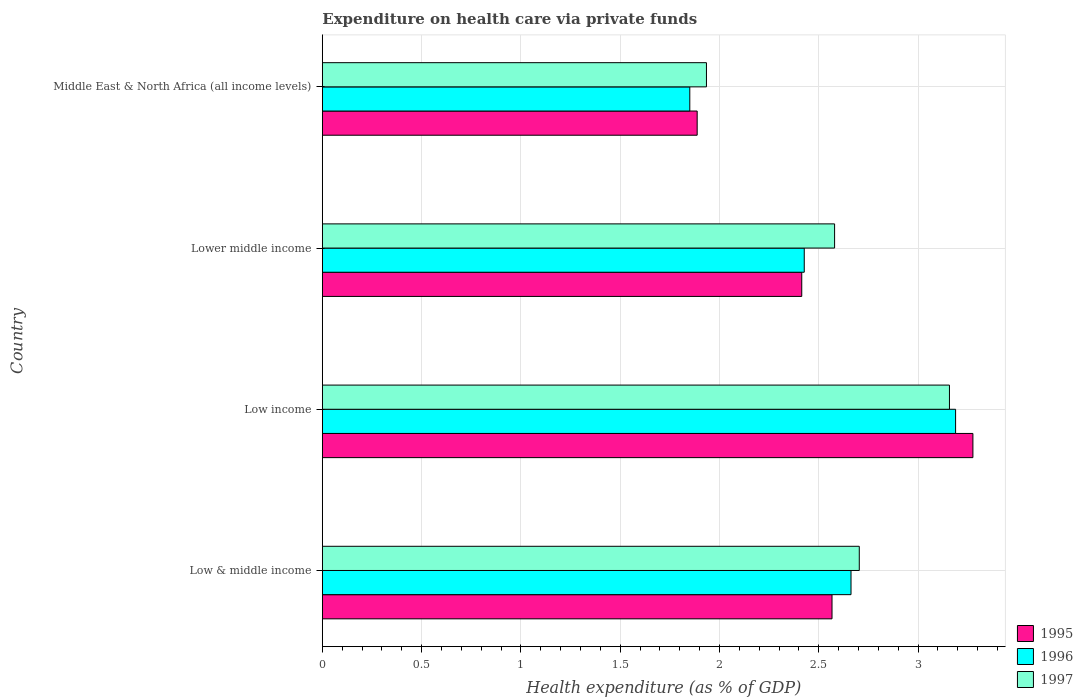How many different coloured bars are there?
Offer a terse response. 3. How many groups of bars are there?
Keep it short and to the point. 4. Are the number of bars on each tick of the Y-axis equal?
Offer a very short reply. Yes. How many bars are there on the 4th tick from the top?
Your response must be concise. 3. In how many cases, is the number of bars for a given country not equal to the number of legend labels?
Ensure brevity in your answer.  0. What is the expenditure made on health care in 1996 in Low income?
Keep it short and to the point. 3.19. Across all countries, what is the maximum expenditure made on health care in 1997?
Your answer should be compact. 3.16. Across all countries, what is the minimum expenditure made on health care in 1997?
Ensure brevity in your answer.  1.93. In which country was the expenditure made on health care in 1997 maximum?
Offer a very short reply. Low income. In which country was the expenditure made on health care in 1996 minimum?
Make the answer very short. Middle East & North Africa (all income levels). What is the total expenditure made on health care in 1996 in the graph?
Your answer should be very brief. 10.13. What is the difference between the expenditure made on health care in 1995 in Lower middle income and that in Middle East & North Africa (all income levels)?
Make the answer very short. 0.53. What is the difference between the expenditure made on health care in 1995 in Lower middle income and the expenditure made on health care in 1996 in Low income?
Your answer should be very brief. -0.77. What is the average expenditure made on health care in 1996 per country?
Your answer should be compact. 2.53. What is the difference between the expenditure made on health care in 1996 and expenditure made on health care in 1997 in Low income?
Your answer should be compact. 0.03. In how many countries, is the expenditure made on health care in 1996 greater than 1.2 %?
Your answer should be compact. 4. What is the ratio of the expenditure made on health care in 1996 in Low income to that in Middle East & North Africa (all income levels)?
Offer a terse response. 1.72. Is the expenditure made on health care in 1997 in Low income less than that in Lower middle income?
Your answer should be very brief. No. Is the difference between the expenditure made on health care in 1996 in Low & middle income and Low income greater than the difference between the expenditure made on health care in 1997 in Low & middle income and Low income?
Give a very brief answer. No. What is the difference between the highest and the second highest expenditure made on health care in 1996?
Your response must be concise. 0.53. What is the difference between the highest and the lowest expenditure made on health care in 1996?
Make the answer very short. 1.34. In how many countries, is the expenditure made on health care in 1996 greater than the average expenditure made on health care in 1996 taken over all countries?
Ensure brevity in your answer.  2. Is the sum of the expenditure made on health care in 1996 in Low & middle income and Middle East & North Africa (all income levels) greater than the maximum expenditure made on health care in 1995 across all countries?
Provide a succinct answer. Yes. How many bars are there?
Keep it short and to the point. 12. How many countries are there in the graph?
Keep it short and to the point. 4. What is the difference between two consecutive major ticks on the X-axis?
Provide a short and direct response. 0.5. Are the values on the major ticks of X-axis written in scientific E-notation?
Make the answer very short. No. Does the graph contain any zero values?
Give a very brief answer. No. How are the legend labels stacked?
Offer a terse response. Vertical. What is the title of the graph?
Your answer should be very brief. Expenditure on health care via private funds. Does "1989" appear as one of the legend labels in the graph?
Give a very brief answer. No. What is the label or title of the X-axis?
Your answer should be compact. Health expenditure (as % of GDP). What is the Health expenditure (as % of GDP) in 1995 in Low & middle income?
Provide a succinct answer. 2.57. What is the Health expenditure (as % of GDP) of 1996 in Low & middle income?
Your answer should be very brief. 2.66. What is the Health expenditure (as % of GDP) of 1997 in Low & middle income?
Your response must be concise. 2.7. What is the Health expenditure (as % of GDP) of 1995 in Low income?
Provide a short and direct response. 3.28. What is the Health expenditure (as % of GDP) of 1996 in Low income?
Ensure brevity in your answer.  3.19. What is the Health expenditure (as % of GDP) of 1997 in Low income?
Give a very brief answer. 3.16. What is the Health expenditure (as % of GDP) in 1995 in Lower middle income?
Give a very brief answer. 2.41. What is the Health expenditure (as % of GDP) of 1996 in Lower middle income?
Your answer should be very brief. 2.43. What is the Health expenditure (as % of GDP) of 1997 in Lower middle income?
Keep it short and to the point. 2.58. What is the Health expenditure (as % of GDP) of 1995 in Middle East & North Africa (all income levels)?
Your answer should be very brief. 1.89. What is the Health expenditure (as % of GDP) of 1996 in Middle East & North Africa (all income levels)?
Your answer should be very brief. 1.85. What is the Health expenditure (as % of GDP) of 1997 in Middle East & North Africa (all income levels)?
Offer a very short reply. 1.93. Across all countries, what is the maximum Health expenditure (as % of GDP) in 1995?
Your response must be concise. 3.28. Across all countries, what is the maximum Health expenditure (as % of GDP) of 1996?
Your response must be concise. 3.19. Across all countries, what is the maximum Health expenditure (as % of GDP) of 1997?
Your answer should be compact. 3.16. Across all countries, what is the minimum Health expenditure (as % of GDP) in 1995?
Your response must be concise. 1.89. Across all countries, what is the minimum Health expenditure (as % of GDP) in 1996?
Ensure brevity in your answer.  1.85. Across all countries, what is the minimum Health expenditure (as % of GDP) of 1997?
Provide a short and direct response. 1.93. What is the total Health expenditure (as % of GDP) in 1995 in the graph?
Keep it short and to the point. 10.15. What is the total Health expenditure (as % of GDP) of 1996 in the graph?
Ensure brevity in your answer.  10.13. What is the total Health expenditure (as % of GDP) of 1997 in the graph?
Provide a short and direct response. 10.38. What is the difference between the Health expenditure (as % of GDP) of 1995 in Low & middle income and that in Low income?
Your response must be concise. -0.71. What is the difference between the Health expenditure (as % of GDP) in 1996 in Low & middle income and that in Low income?
Offer a very short reply. -0.53. What is the difference between the Health expenditure (as % of GDP) in 1997 in Low & middle income and that in Low income?
Give a very brief answer. -0.45. What is the difference between the Health expenditure (as % of GDP) of 1995 in Low & middle income and that in Lower middle income?
Provide a succinct answer. 0.15. What is the difference between the Health expenditure (as % of GDP) in 1996 in Low & middle income and that in Lower middle income?
Your response must be concise. 0.24. What is the difference between the Health expenditure (as % of GDP) in 1997 in Low & middle income and that in Lower middle income?
Offer a terse response. 0.12. What is the difference between the Health expenditure (as % of GDP) in 1995 in Low & middle income and that in Middle East & North Africa (all income levels)?
Your answer should be compact. 0.68. What is the difference between the Health expenditure (as % of GDP) of 1996 in Low & middle income and that in Middle East & North Africa (all income levels)?
Ensure brevity in your answer.  0.81. What is the difference between the Health expenditure (as % of GDP) of 1997 in Low & middle income and that in Middle East & North Africa (all income levels)?
Your answer should be very brief. 0.77. What is the difference between the Health expenditure (as % of GDP) of 1995 in Low income and that in Lower middle income?
Keep it short and to the point. 0.86. What is the difference between the Health expenditure (as % of GDP) in 1996 in Low income and that in Lower middle income?
Ensure brevity in your answer.  0.76. What is the difference between the Health expenditure (as % of GDP) in 1997 in Low income and that in Lower middle income?
Your answer should be very brief. 0.58. What is the difference between the Health expenditure (as % of GDP) of 1995 in Low income and that in Middle East & North Africa (all income levels)?
Your answer should be very brief. 1.39. What is the difference between the Health expenditure (as % of GDP) in 1996 in Low income and that in Middle East & North Africa (all income levels)?
Make the answer very short. 1.34. What is the difference between the Health expenditure (as % of GDP) in 1997 in Low income and that in Middle East & North Africa (all income levels)?
Offer a very short reply. 1.22. What is the difference between the Health expenditure (as % of GDP) of 1995 in Lower middle income and that in Middle East & North Africa (all income levels)?
Your answer should be compact. 0.53. What is the difference between the Health expenditure (as % of GDP) of 1996 in Lower middle income and that in Middle East & North Africa (all income levels)?
Your answer should be very brief. 0.58. What is the difference between the Health expenditure (as % of GDP) of 1997 in Lower middle income and that in Middle East & North Africa (all income levels)?
Offer a very short reply. 0.65. What is the difference between the Health expenditure (as % of GDP) in 1995 in Low & middle income and the Health expenditure (as % of GDP) in 1996 in Low income?
Provide a short and direct response. -0.62. What is the difference between the Health expenditure (as % of GDP) of 1995 in Low & middle income and the Health expenditure (as % of GDP) of 1997 in Low income?
Provide a short and direct response. -0.59. What is the difference between the Health expenditure (as % of GDP) in 1996 in Low & middle income and the Health expenditure (as % of GDP) in 1997 in Low income?
Provide a succinct answer. -0.5. What is the difference between the Health expenditure (as % of GDP) of 1995 in Low & middle income and the Health expenditure (as % of GDP) of 1996 in Lower middle income?
Your response must be concise. 0.14. What is the difference between the Health expenditure (as % of GDP) of 1995 in Low & middle income and the Health expenditure (as % of GDP) of 1997 in Lower middle income?
Your response must be concise. -0.01. What is the difference between the Health expenditure (as % of GDP) in 1996 in Low & middle income and the Health expenditure (as % of GDP) in 1997 in Lower middle income?
Make the answer very short. 0.08. What is the difference between the Health expenditure (as % of GDP) of 1995 in Low & middle income and the Health expenditure (as % of GDP) of 1996 in Middle East & North Africa (all income levels)?
Provide a succinct answer. 0.72. What is the difference between the Health expenditure (as % of GDP) in 1995 in Low & middle income and the Health expenditure (as % of GDP) in 1997 in Middle East & North Africa (all income levels)?
Ensure brevity in your answer.  0.63. What is the difference between the Health expenditure (as % of GDP) in 1996 in Low & middle income and the Health expenditure (as % of GDP) in 1997 in Middle East & North Africa (all income levels)?
Offer a very short reply. 0.73. What is the difference between the Health expenditure (as % of GDP) in 1995 in Low income and the Health expenditure (as % of GDP) in 1996 in Lower middle income?
Provide a succinct answer. 0.85. What is the difference between the Health expenditure (as % of GDP) of 1995 in Low income and the Health expenditure (as % of GDP) of 1997 in Lower middle income?
Your answer should be very brief. 0.7. What is the difference between the Health expenditure (as % of GDP) in 1996 in Low income and the Health expenditure (as % of GDP) in 1997 in Lower middle income?
Ensure brevity in your answer.  0.61. What is the difference between the Health expenditure (as % of GDP) of 1995 in Low income and the Health expenditure (as % of GDP) of 1996 in Middle East & North Africa (all income levels)?
Make the answer very short. 1.43. What is the difference between the Health expenditure (as % of GDP) of 1995 in Low income and the Health expenditure (as % of GDP) of 1997 in Middle East & North Africa (all income levels)?
Give a very brief answer. 1.34. What is the difference between the Health expenditure (as % of GDP) of 1996 in Low income and the Health expenditure (as % of GDP) of 1997 in Middle East & North Africa (all income levels)?
Your response must be concise. 1.25. What is the difference between the Health expenditure (as % of GDP) in 1995 in Lower middle income and the Health expenditure (as % of GDP) in 1996 in Middle East & North Africa (all income levels)?
Keep it short and to the point. 0.56. What is the difference between the Health expenditure (as % of GDP) in 1995 in Lower middle income and the Health expenditure (as % of GDP) in 1997 in Middle East & North Africa (all income levels)?
Keep it short and to the point. 0.48. What is the difference between the Health expenditure (as % of GDP) in 1996 in Lower middle income and the Health expenditure (as % of GDP) in 1997 in Middle East & North Africa (all income levels)?
Provide a short and direct response. 0.49. What is the average Health expenditure (as % of GDP) in 1995 per country?
Your answer should be compact. 2.54. What is the average Health expenditure (as % of GDP) of 1996 per country?
Offer a very short reply. 2.53. What is the average Health expenditure (as % of GDP) in 1997 per country?
Keep it short and to the point. 2.59. What is the difference between the Health expenditure (as % of GDP) in 1995 and Health expenditure (as % of GDP) in 1996 in Low & middle income?
Give a very brief answer. -0.1. What is the difference between the Health expenditure (as % of GDP) in 1995 and Health expenditure (as % of GDP) in 1997 in Low & middle income?
Offer a terse response. -0.14. What is the difference between the Health expenditure (as % of GDP) of 1996 and Health expenditure (as % of GDP) of 1997 in Low & middle income?
Your answer should be compact. -0.04. What is the difference between the Health expenditure (as % of GDP) in 1995 and Health expenditure (as % of GDP) in 1996 in Low income?
Your answer should be very brief. 0.09. What is the difference between the Health expenditure (as % of GDP) of 1995 and Health expenditure (as % of GDP) of 1997 in Low income?
Offer a very short reply. 0.12. What is the difference between the Health expenditure (as % of GDP) in 1996 and Health expenditure (as % of GDP) in 1997 in Low income?
Your answer should be very brief. 0.03. What is the difference between the Health expenditure (as % of GDP) of 1995 and Health expenditure (as % of GDP) of 1996 in Lower middle income?
Provide a short and direct response. -0.01. What is the difference between the Health expenditure (as % of GDP) in 1995 and Health expenditure (as % of GDP) in 1997 in Lower middle income?
Make the answer very short. -0.17. What is the difference between the Health expenditure (as % of GDP) of 1996 and Health expenditure (as % of GDP) of 1997 in Lower middle income?
Offer a terse response. -0.15. What is the difference between the Health expenditure (as % of GDP) in 1995 and Health expenditure (as % of GDP) in 1996 in Middle East & North Africa (all income levels)?
Provide a short and direct response. 0.04. What is the difference between the Health expenditure (as % of GDP) in 1995 and Health expenditure (as % of GDP) in 1997 in Middle East & North Africa (all income levels)?
Give a very brief answer. -0.05. What is the difference between the Health expenditure (as % of GDP) of 1996 and Health expenditure (as % of GDP) of 1997 in Middle East & North Africa (all income levels)?
Ensure brevity in your answer.  -0.08. What is the ratio of the Health expenditure (as % of GDP) in 1995 in Low & middle income to that in Low income?
Your answer should be compact. 0.78. What is the ratio of the Health expenditure (as % of GDP) in 1996 in Low & middle income to that in Low income?
Keep it short and to the point. 0.83. What is the ratio of the Health expenditure (as % of GDP) in 1997 in Low & middle income to that in Low income?
Provide a succinct answer. 0.86. What is the ratio of the Health expenditure (as % of GDP) of 1995 in Low & middle income to that in Lower middle income?
Provide a short and direct response. 1.06. What is the ratio of the Health expenditure (as % of GDP) in 1996 in Low & middle income to that in Lower middle income?
Your answer should be very brief. 1.1. What is the ratio of the Health expenditure (as % of GDP) in 1997 in Low & middle income to that in Lower middle income?
Provide a short and direct response. 1.05. What is the ratio of the Health expenditure (as % of GDP) in 1995 in Low & middle income to that in Middle East & North Africa (all income levels)?
Ensure brevity in your answer.  1.36. What is the ratio of the Health expenditure (as % of GDP) in 1996 in Low & middle income to that in Middle East & North Africa (all income levels)?
Your response must be concise. 1.44. What is the ratio of the Health expenditure (as % of GDP) in 1997 in Low & middle income to that in Middle East & North Africa (all income levels)?
Offer a terse response. 1.4. What is the ratio of the Health expenditure (as % of GDP) in 1995 in Low income to that in Lower middle income?
Make the answer very short. 1.36. What is the ratio of the Health expenditure (as % of GDP) of 1996 in Low income to that in Lower middle income?
Your response must be concise. 1.31. What is the ratio of the Health expenditure (as % of GDP) in 1997 in Low income to that in Lower middle income?
Keep it short and to the point. 1.22. What is the ratio of the Health expenditure (as % of GDP) of 1995 in Low income to that in Middle East & North Africa (all income levels)?
Provide a succinct answer. 1.74. What is the ratio of the Health expenditure (as % of GDP) of 1996 in Low income to that in Middle East & North Africa (all income levels)?
Make the answer very short. 1.72. What is the ratio of the Health expenditure (as % of GDP) in 1997 in Low income to that in Middle East & North Africa (all income levels)?
Provide a succinct answer. 1.63. What is the ratio of the Health expenditure (as % of GDP) in 1995 in Lower middle income to that in Middle East & North Africa (all income levels)?
Offer a terse response. 1.28. What is the ratio of the Health expenditure (as % of GDP) in 1996 in Lower middle income to that in Middle East & North Africa (all income levels)?
Provide a short and direct response. 1.31. What is the ratio of the Health expenditure (as % of GDP) of 1997 in Lower middle income to that in Middle East & North Africa (all income levels)?
Provide a succinct answer. 1.33. What is the difference between the highest and the second highest Health expenditure (as % of GDP) of 1995?
Offer a very short reply. 0.71. What is the difference between the highest and the second highest Health expenditure (as % of GDP) in 1996?
Provide a short and direct response. 0.53. What is the difference between the highest and the second highest Health expenditure (as % of GDP) in 1997?
Your answer should be compact. 0.45. What is the difference between the highest and the lowest Health expenditure (as % of GDP) of 1995?
Your answer should be very brief. 1.39. What is the difference between the highest and the lowest Health expenditure (as % of GDP) in 1996?
Ensure brevity in your answer.  1.34. What is the difference between the highest and the lowest Health expenditure (as % of GDP) in 1997?
Offer a very short reply. 1.22. 